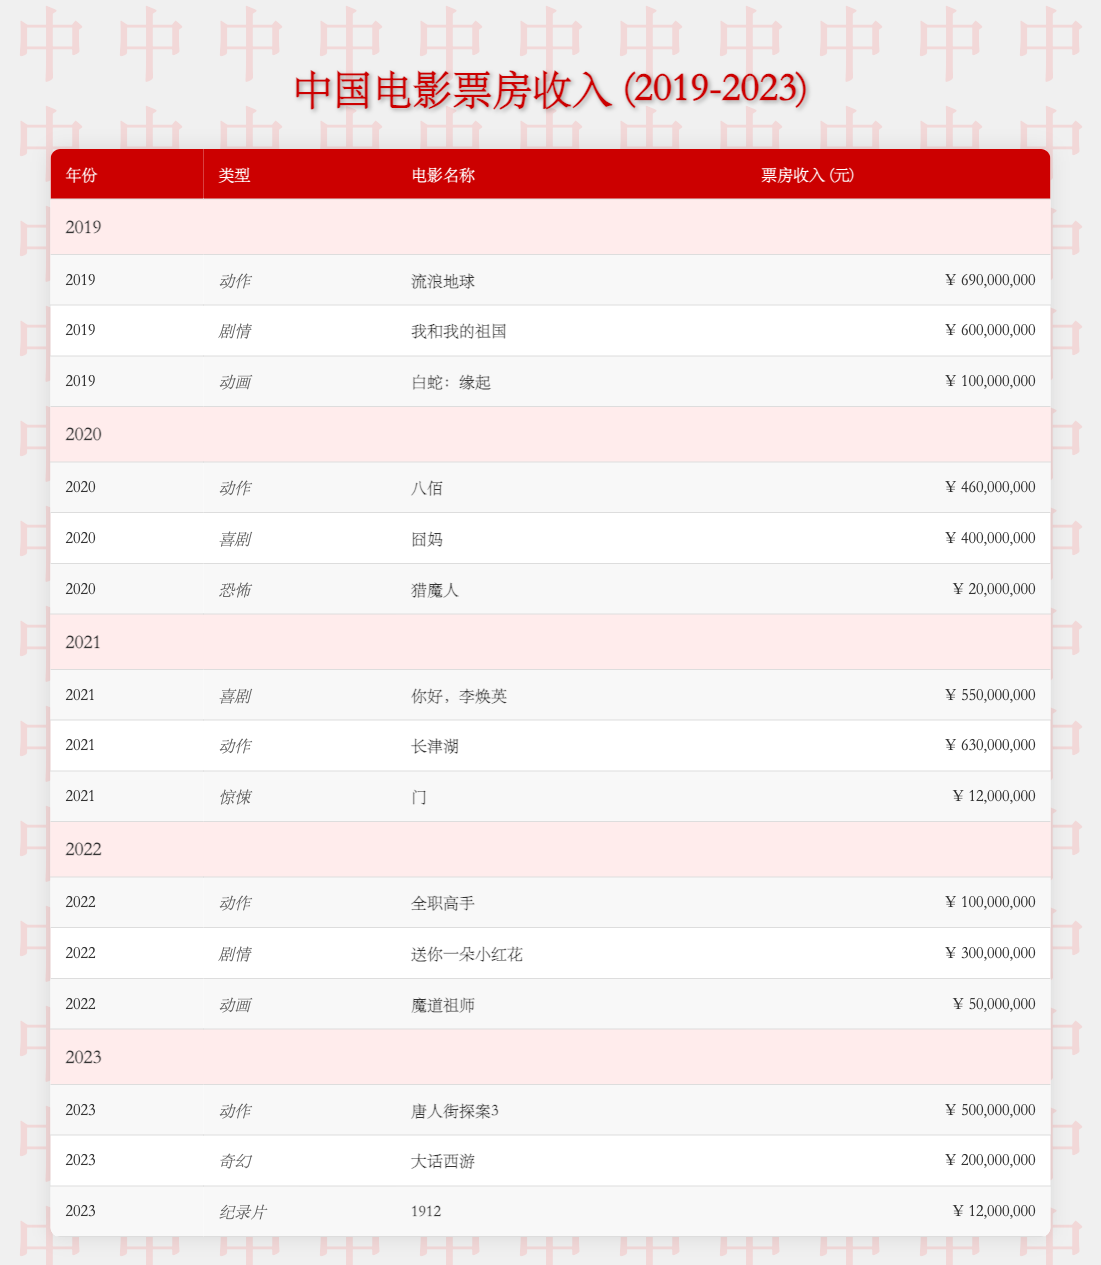What is the highest-grossing action movie in 2019? In 2019, the action movie "The Wandering Earth" had a revenue of 690,000,000. By checking the action movies listed for that year in the table, it is clear that this title has the highest revenue compared to any other action movies in that year.
Answer: The Wandering Earth Which genre had the lowest box office revenue in 2020? In 2020, the genre with the lowest revenue is horror, with "Demon Hunter" earning only 20,000,000. By comparing the earnings across the different genres for that year, horror has the least amount.
Answer: Horror What is the total box office revenue from the drama genre across all years? To calculate the total revenue from the drama genre, we sum the revenues from the dramas listed: 600,000,000 (2019, "My People, My Country") + 300,000,000 (2022, "A Little Red Flower") = 900,000,000. There are no dramas recorded in 2020, 2021, and 2023.
Answer: 900,000,000 Did any animated films exceed 100 million in revenue between 2019 and 2023? Checking all the animated films in the provided years shows that in 2019, "White Snake" earned 100,000,000, and in 2022, "Mo Dao Zu Shi" earned 50,000,000. Neither of these animated films exceeded 100 million, so the answer is no.
Answer: No What is the average box office revenue for action movies from 2021 to 2023? The action films from 2021 to 2023 have the following revenues: 630,000,000 (2021, "The Battle at Lake Changjin") + 100,000,000 (2022, "The King's Avatar") + 500,000,000 (2023, "Detective Chinatown 3") = 1,230,000,000 total revenue. There are 3 action films in total, so the average revenue is 1,230,000,000 / 3 = 410,000,000.
Answer: 410,000,000 Which year had the highest total revenue from all genres combined? To determine which year had the highest total revenue, we must sum the revenues for each year: 2019 = 690,000,000 + 600,000,000 + 100,000,000 = 1,390,000,000; 2020 = 460,000,000 + 400,000,000 + 20,000,000 = 880,000,000; 2021 = 630,000,000 + 550,000,000 + 12,000,000 = 1,192,000,000; 2022 = 100,000,000 + 300,000,000 + 50,000,000 = 450,000,000; 2023 = 500,000,000 + 200,000,000 + 12,000,000 = 712,000,000. 2019 has the highest total revenue at 1,390,000,000.
Answer: 2019 In 2023, what was the revenue difference between the highest and lowest-grossing films? Analyzing the revenue for 2023, the highest-grossing film is "Detective Chinatown 3" with 500,000,000, while the lowest-grossing film, "1912", earned 12,000,000. The difference is calculated as 500,000,000 - 12,000,000 = 488,000,000.
Answer: 488,000,000 Is "A Little Red Flower" the highest-grossing drama movie in 2022? In 2022, the drama movie "A Little Red Flower" grossed 300,000,000, which is the only drama in that year. Therefore, it is indeed the highest-grossing drama for that year.
Answer: Yes 